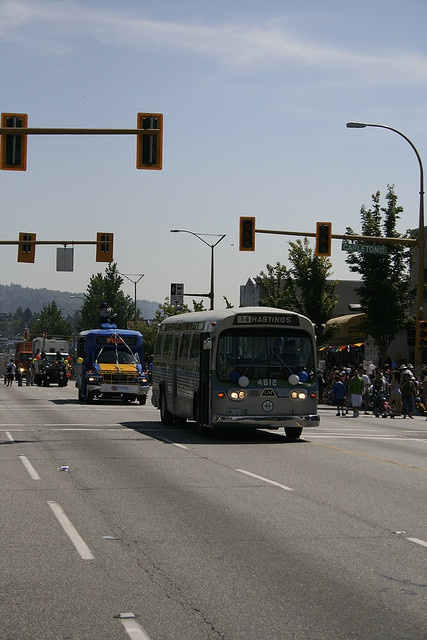Describe the objects in this image and their specific colors. I can see bus in darkgray, black, and gray tones, truck in darkgray, black, gray, navy, and olive tones, people in darkgray, black, gray, and maroon tones, traffic light in darkgray, black, maroon, and gray tones, and traffic light in darkgray, black, maroon, and gray tones in this image. 